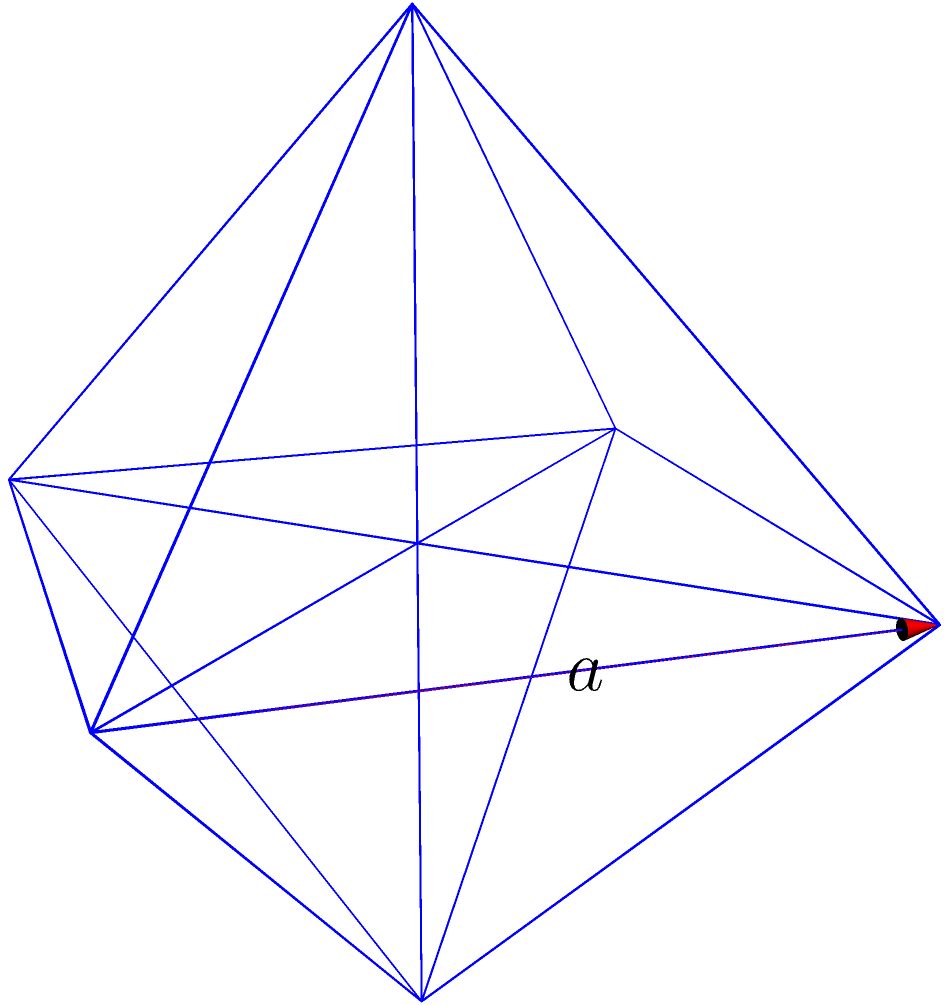Remember our discussions about Platonic solids back in college? Here's a question that might interest you: If the edge length of a regular octahedron is $a$ units, what is its surface area? Let's approach this step-by-step, old friend:

1) Recall that a regular octahedron has 8 equilateral triangular faces.

2) The surface area will be the sum of the areas of these 8 triangles.

3) For an equilateral triangle with side length $a$, the area is given by:

   $$A_{triangle} = \frac{\sqrt{3}}{4}a^2$$

4) Since there are 8 such triangles, the total surface area will be:

   $$SA_{octahedron} = 8 \times \frac{\sqrt{3}}{4}a^2$$

5) Simplifying:

   $$SA_{octahedron} = 2\sqrt{3}a^2$$

Therefore, the surface area of a regular octahedron with edge length $a$ is $2\sqrt{3}a^2$ square units.
Answer: $2\sqrt{3}a^2$ 